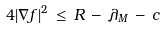<formula> <loc_0><loc_0><loc_500><loc_500>4 | \nabla f | ^ { 2 } \, \leq \, R \, - \, \lambda _ { M } \, - \, c</formula> 